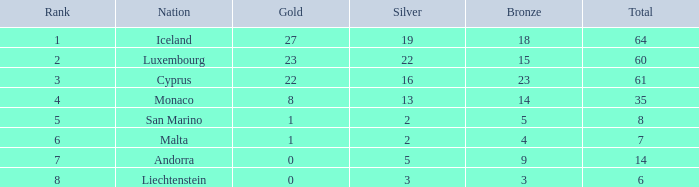How many bronzes for nations with over 22 golds and ranked under 2? 18.0. 